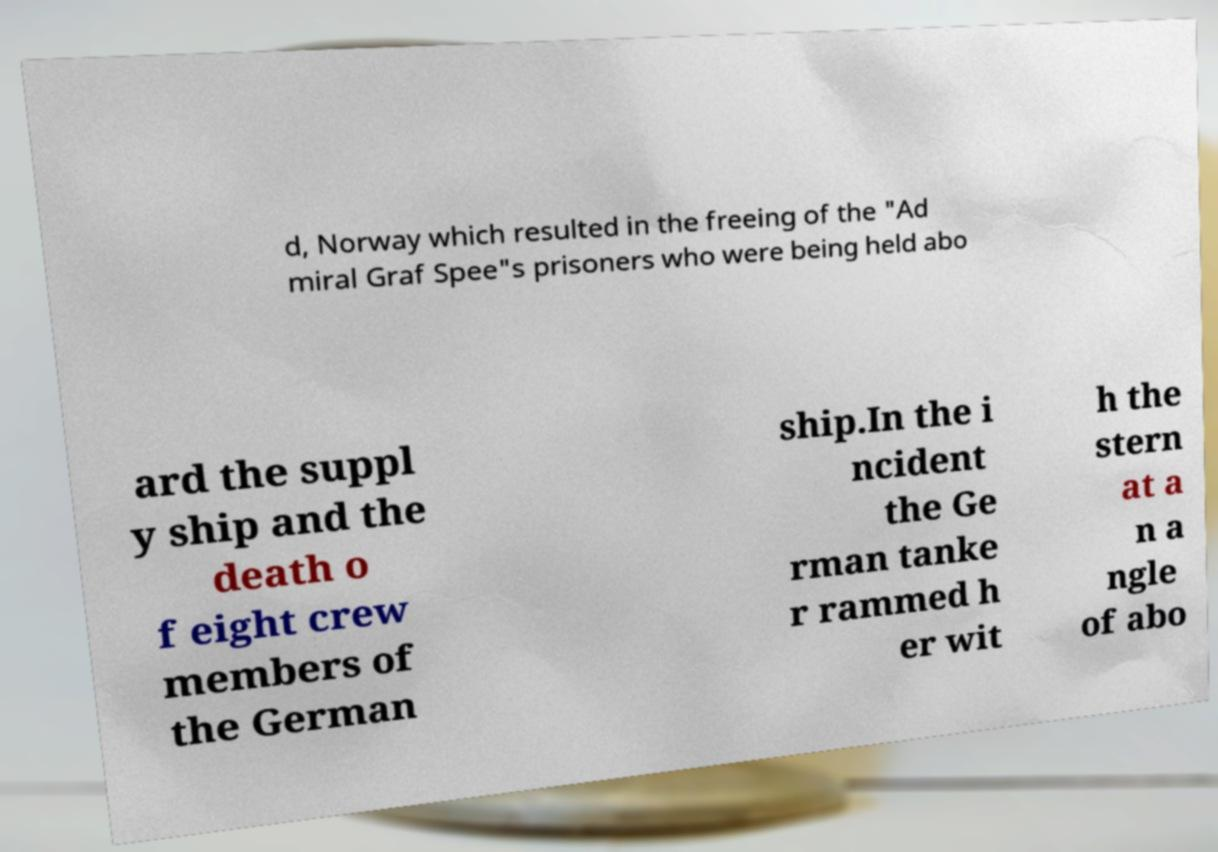Please identify and transcribe the text found in this image. d, Norway which resulted in the freeing of the "Ad miral Graf Spee"s prisoners who were being held abo ard the suppl y ship and the death o f eight crew members of the German ship.In the i ncident the Ge rman tanke r rammed h er wit h the stern at a n a ngle of abo 